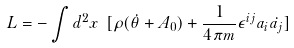Convert formula to latex. <formula><loc_0><loc_0><loc_500><loc_500>L = - \int d ^ { 2 } x \ [ \rho ( \dot { \theta } + A _ { 0 } ) + { \frac { 1 } { 4 \pi m } } \epsilon ^ { i j } a _ { i } \dot { a _ { j } } ]</formula> 